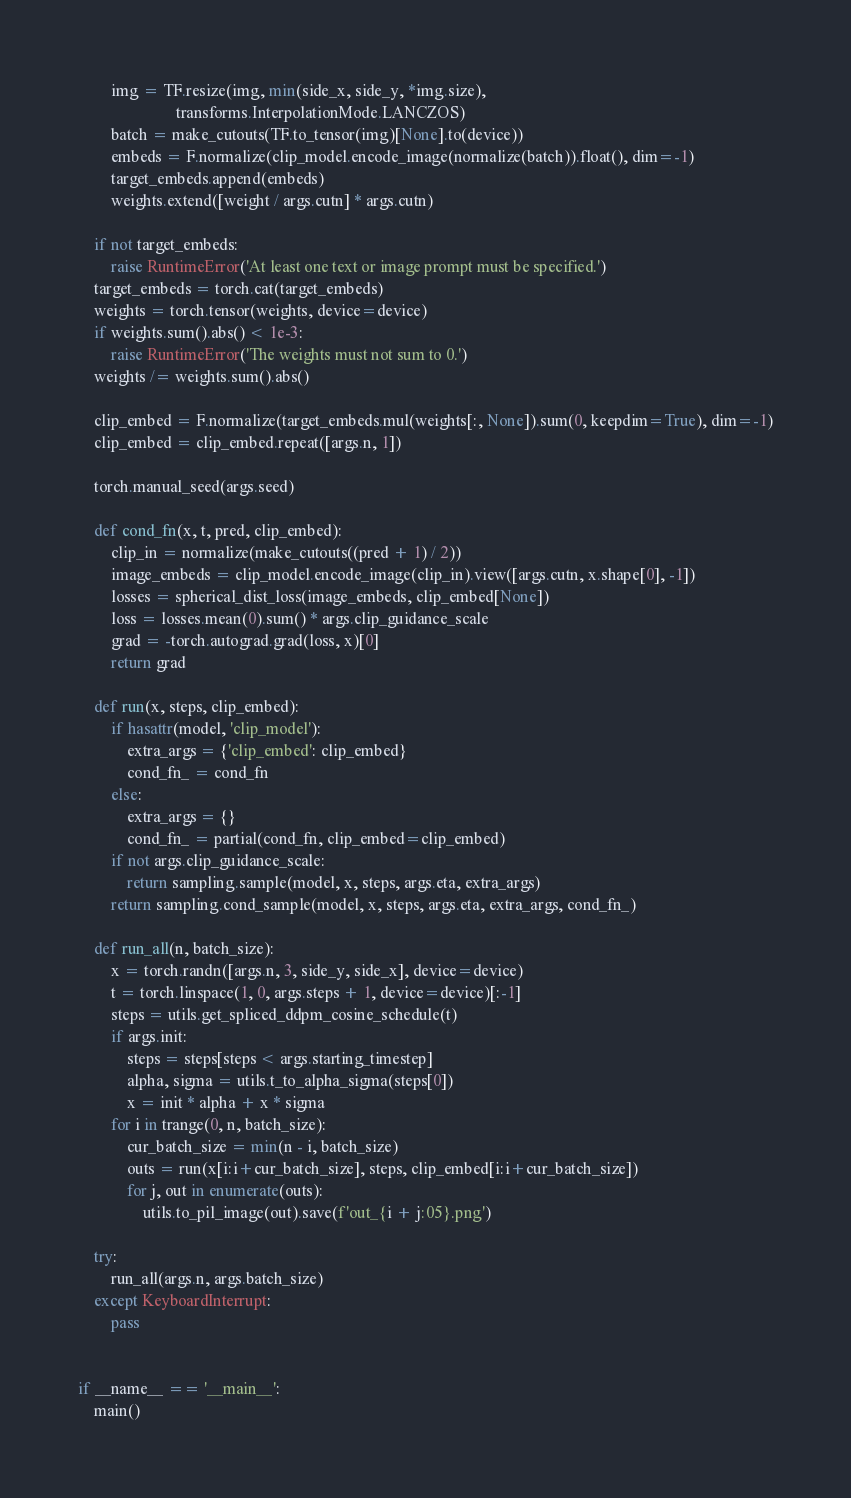Convert code to text. <code><loc_0><loc_0><loc_500><loc_500><_Python_>        img = TF.resize(img, min(side_x, side_y, *img.size),
                        transforms.InterpolationMode.LANCZOS)
        batch = make_cutouts(TF.to_tensor(img)[None].to(device))
        embeds = F.normalize(clip_model.encode_image(normalize(batch)).float(), dim=-1)
        target_embeds.append(embeds)
        weights.extend([weight / args.cutn] * args.cutn)

    if not target_embeds:
        raise RuntimeError('At least one text or image prompt must be specified.')
    target_embeds = torch.cat(target_embeds)
    weights = torch.tensor(weights, device=device)
    if weights.sum().abs() < 1e-3:
        raise RuntimeError('The weights must not sum to 0.')
    weights /= weights.sum().abs()

    clip_embed = F.normalize(target_embeds.mul(weights[:, None]).sum(0, keepdim=True), dim=-1)
    clip_embed = clip_embed.repeat([args.n, 1])

    torch.manual_seed(args.seed)

    def cond_fn(x, t, pred, clip_embed):
        clip_in = normalize(make_cutouts((pred + 1) / 2))
        image_embeds = clip_model.encode_image(clip_in).view([args.cutn, x.shape[0], -1])
        losses = spherical_dist_loss(image_embeds, clip_embed[None])
        loss = losses.mean(0).sum() * args.clip_guidance_scale
        grad = -torch.autograd.grad(loss, x)[0]
        return grad

    def run(x, steps, clip_embed):
        if hasattr(model, 'clip_model'):
            extra_args = {'clip_embed': clip_embed}
            cond_fn_ = cond_fn
        else:
            extra_args = {}
            cond_fn_ = partial(cond_fn, clip_embed=clip_embed)
        if not args.clip_guidance_scale:
            return sampling.sample(model, x, steps, args.eta, extra_args)
        return sampling.cond_sample(model, x, steps, args.eta, extra_args, cond_fn_)

    def run_all(n, batch_size):
        x = torch.randn([args.n, 3, side_y, side_x], device=device)
        t = torch.linspace(1, 0, args.steps + 1, device=device)[:-1]
        steps = utils.get_spliced_ddpm_cosine_schedule(t)
        if args.init:
            steps = steps[steps < args.starting_timestep]
            alpha, sigma = utils.t_to_alpha_sigma(steps[0])
            x = init * alpha + x * sigma
        for i in trange(0, n, batch_size):
            cur_batch_size = min(n - i, batch_size)
            outs = run(x[i:i+cur_batch_size], steps, clip_embed[i:i+cur_batch_size])
            for j, out in enumerate(outs):
                utils.to_pil_image(out).save(f'out_{i + j:05}.png')

    try:
        run_all(args.n, args.batch_size)
    except KeyboardInterrupt:
        pass


if __name__ == '__main__':
    main()
</code> 